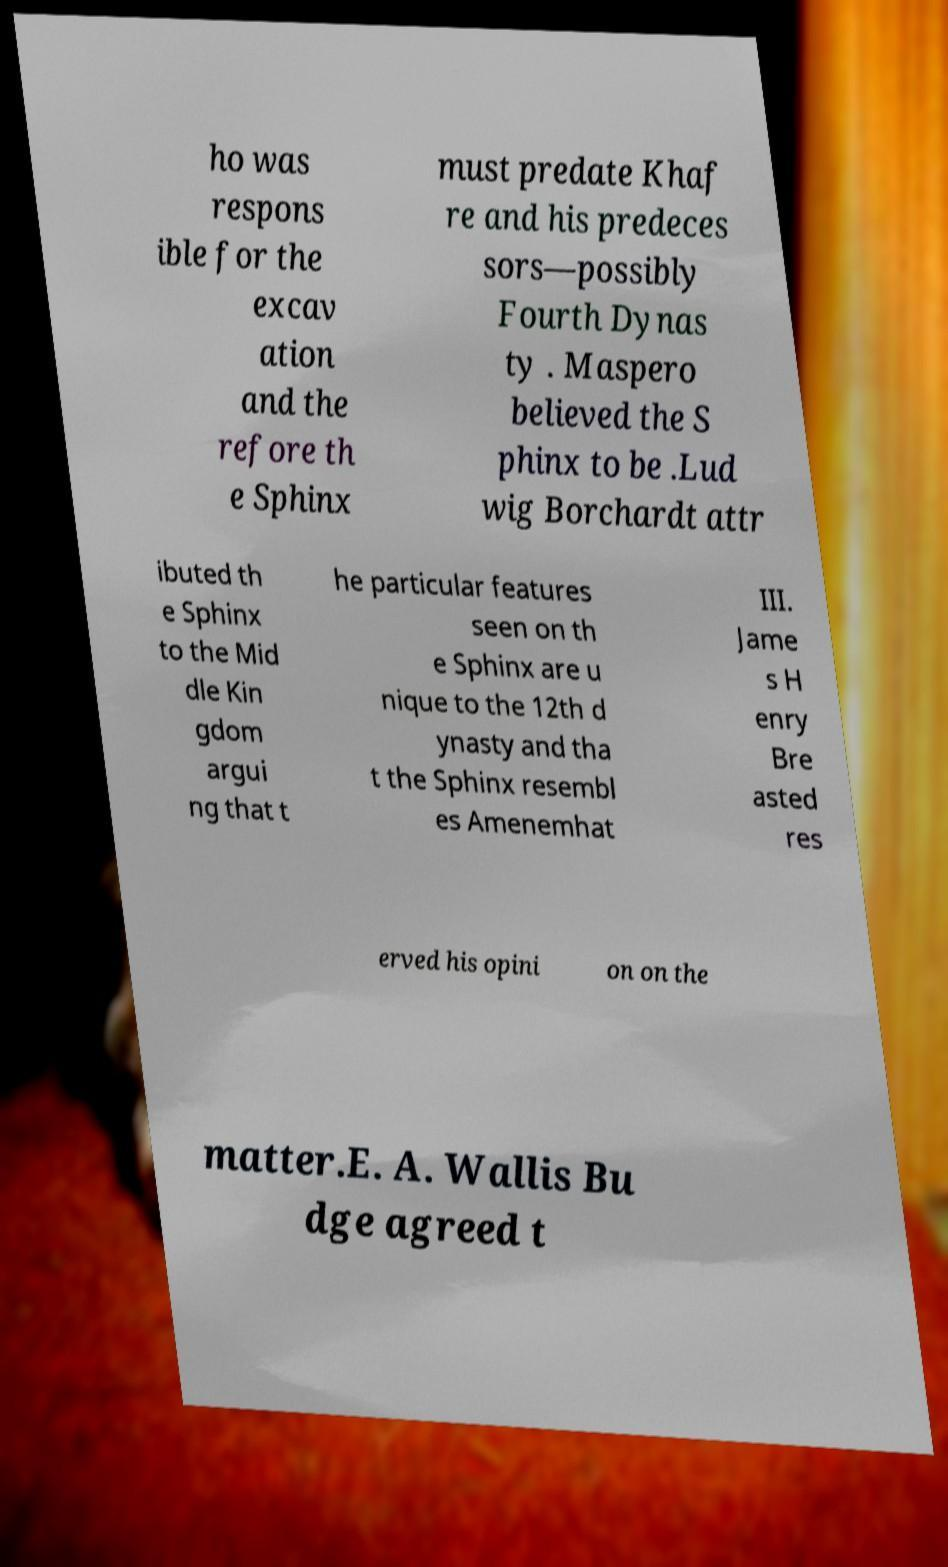Could you assist in decoding the text presented in this image and type it out clearly? ho was respons ible for the excav ation and the refore th e Sphinx must predate Khaf re and his predeces sors—possibly Fourth Dynas ty . Maspero believed the S phinx to be .Lud wig Borchardt attr ibuted th e Sphinx to the Mid dle Kin gdom argui ng that t he particular features seen on th e Sphinx are u nique to the 12th d ynasty and tha t the Sphinx resembl es Amenemhat III. Jame s H enry Bre asted res erved his opini on on the matter.E. A. Wallis Bu dge agreed t 